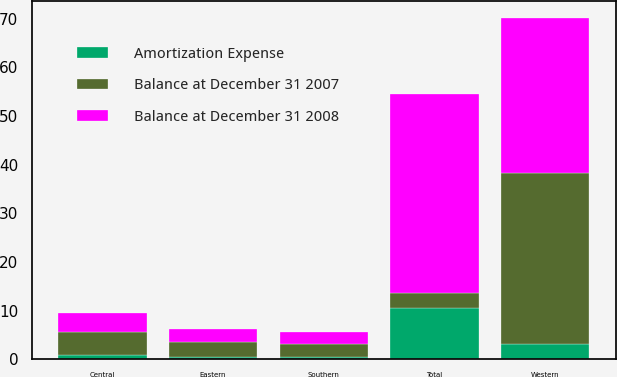<chart> <loc_0><loc_0><loc_500><loc_500><stacked_bar_chart><ecel><fcel>Eastern<fcel>Central<fcel>Southern<fcel>Western<fcel>Total<nl><fcel>Balance at December 31 2008<fcel>2.6<fcel>3.9<fcel>2.4<fcel>31.9<fcel>40.8<nl><fcel>Amortization Expense<fcel>0.5<fcel>0.8<fcel>0.4<fcel>3.2<fcel>10.5<nl><fcel>Balance at December 31 2007<fcel>3.1<fcel>4.7<fcel>2.8<fcel>35.1<fcel>3.15<nl></chart> 